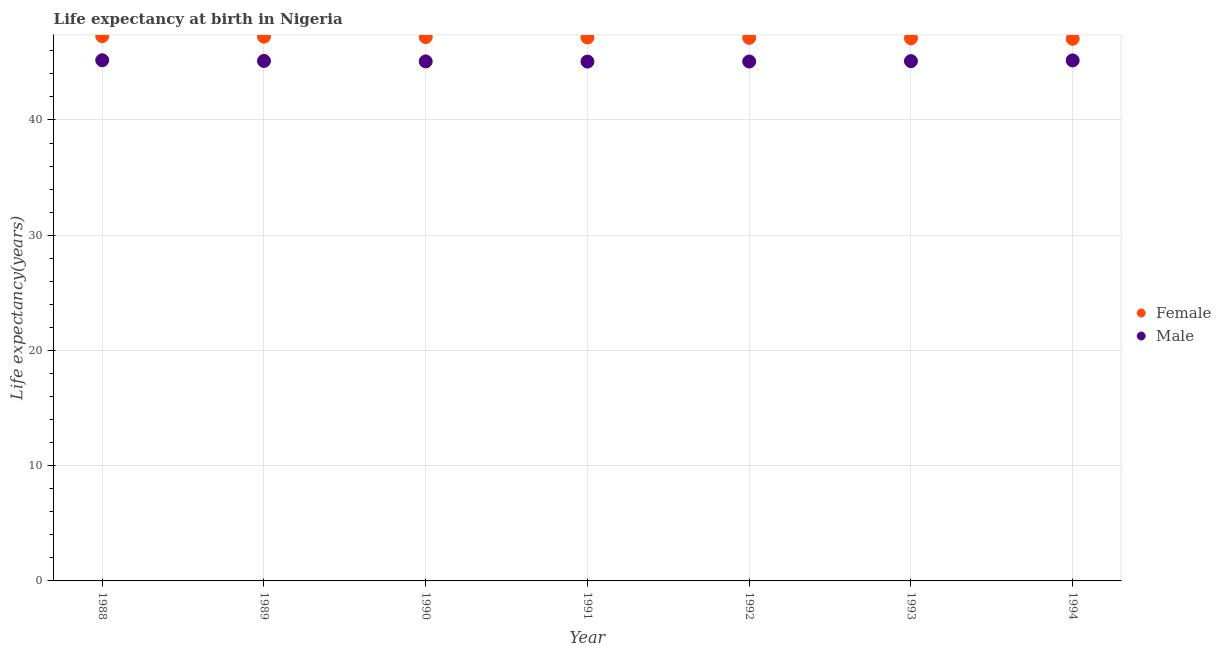How many different coloured dotlines are there?
Offer a terse response. 2. Is the number of dotlines equal to the number of legend labels?
Give a very brief answer. Yes. What is the life expectancy(male) in 1993?
Keep it short and to the point. 45.11. Across all years, what is the maximum life expectancy(female)?
Offer a very short reply. 47.27. Across all years, what is the minimum life expectancy(male)?
Keep it short and to the point. 45.06. In which year was the life expectancy(female) maximum?
Give a very brief answer. 1988. What is the total life expectancy(male) in the graph?
Offer a terse response. 315.8. What is the difference between the life expectancy(female) in 1990 and that in 1993?
Keep it short and to the point. 0.1. What is the difference between the life expectancy(male) in 1990 and the life expectancy(female) in 1991?
Offer a terse response. -2.08. What is the average life expectancy(female) per year?
Keep it short and to the point. 47.16. In the year 1989, what is the difference between the life expectancy(female) and life expectancy(male)?
Ensure brevity in your answer.  2.1. In how many years, is the life expectancy(male) greater than 32 years?
Make the answer very short. 7. What is the ratio of the life expectancy(male) in 1989 to that in 1991?
Make the answer very short. 1. Is the difference between the life expectancy(female) in 1989 and 1991 greater than the difference between the life expectancy(male) in 1989 and 1991?
Keep it short and to the point. Yes. What is the difference between the highest and the second highest life expectancy(female)?
Your response must be concise. 0.05. What is the difference between the highest and the lowest life expectancy(male)?
Offer a very short reply. 0.12. Is the life expectancy(male) strictly greater than the life expectancy(female) over the years?
Offer a terse response. No. Is the life expectancy(male) strictly less than the life expectancy(female) over the years?
Keep it short and to the point. Yes. Are the values on the major ticks of Y-axis written in scientific E-notation?
Ensure brevity in your answer.  No. Where does the legend appear in the graph?
Offer a terse response. Center right. What is the title of the graph?
Provide a succinct answer. Life expectancy at birth in Nigeria. What is the label or title of the Y-axis?
Provide a short and direct response. Life expectancy(years). What is the Life expectancy(years) in Female in 1988?
Your response must be concise. 47.27. What is the Life expectancy(years) of Male in 1988?
Your response must be concise. 45.18. What is the Life expectancy(years) in Female in 1989?
Provide a succinct answer. 47.23. What is the Life expectancy(years) of Male in 1989?
Make the answer very short. 45.12. What is the Life expectancy(years) in Female in 1990?
Give a very brief answer. 47.19. What is the Life expectancy(years) in Male in 1990?
Give a very brief answer. 45.08. What is the Life expectancy(years) in Female in 1991?
Offer a very short reply. 47.16. What is the Life expectancy(years) in Male in 1991?
Ensure brevity in your answer.  45.06. What is the Life expectancy(years) in Female in 1992?
Offer a very short reply. 47.13. What is the Life expectancy(years) of Male in 1992?
Your answer should be compact. 45.07. What is the Life expectancy(years) of Female in 1993?
Make the answer very short. 47.09. What is the Life expectancy(years) of Male in 1993?
Provide a short and direct response. 45.11. What is the Life expectancy(years) of Female in 1994?
Your response must be concise. 47.05. What is the Life expectancy(years) in Male in 1994?
Make the answer very short. 45.17. Across all years, what is the maximum Life expectancy(years) of Female?
Offer a terse response. 47.27. Across all years, what is the maximum Life expectancy(years) in Male?
Ensure brevity in your answer.  45.18. Across all years, what is the minimum Life expectancy(years) in Female?
Your answer should be compact. 47.05. Across all years, what is the minimum Life expectancy(years) of Male?
Make the answer very short. 45.06. What is the total Life expectancy(years) of Female in the graph?
Ensure brevity in your answer.  330.12. What is the total Life expectancy(years) of Male in the graph?
Ensure brevity in your answer.  315.8. What is the difference between the Life expectancy(years) in Female in 1988 and that in 1989?
Give a very brief answer. 0.05. What is the difference between the Life expectancy(years) in Male in 1988 and that in 1989?
Make the answer very short. 0.06. What is the difference between the Life expectancy(years) in Female in 1988 and that in 1990?
Your response must be concise. 0.08. What is the difference between the Life expectancy(years) in Male in 1988 and that in 1990?
Offer a terse response. 0.1. What is the difference between the Life expectancy(years) of Female in 1988 and that in 1991?
Your answer should be compact. 0.11. What is the difference between the Life expectancy(years) in Male in 1988 and that in 1991?
Give a very brief answer. 0.12. What is the difference between the Life expectancy(years) in Female in 1988 and that in 1992?
Offer a very short reply. 0.15. What is the difference between the Life expectancy(years) of Male in 1988 and that in 1992?
Offer a terse response. 0.11. What is the difference between the Life expectancy(years) of Female in 1988 and that in 1993?
Give a very brief answer. 0.19. What is the difference between the Life expectancy(years) of Male in 1988 and that in 1993?
Give a very brief answer. 0.08. What is the difference between the Life expectancy(years) of Female in 1988 and that in 1994?
Ensure brevity in your answer.  0.23. What is the difference between the Life expectancy(years) in Male in 1988 and that in 1994?
Your answer should be very brief. 0.01. What is the difference between the Life expectancy(years) of Female in 1989 and that in 1990?
Offer a very short reply. 0.04. What is the difference between the Life expectancy(years) of Male in 1989 and that in 1990?
Offer a terse response. 0.04. What is the difference between the Life expectancy(years) of Female in 1989 and that in 1991?
Your response must be concise. 0.07. What is the difference between the Life expectancy(years) of Male in 1989 and that in 1991?
Offer a terse response. 0.06. What is the difference between the Life expectancy(years) in Female in 1989 and that in 1992?
Your answer should be compact. 0.1. What is the difference between the Life expectancy(years) in Female in 1989 and that in 1993?
Your response must be concise. 0.14. What is the difference between the Life expectancy(years) of Male in 1989 and that in 1993?
Offer a terse response. 0.02. What is the difference between the Life expectancy(years) in Female in 1989 and that in 1994?
Offer a terse response. 0.18. What is the difference between the Life expectancy(years) in Male in 1989 and that in 1994?
Make the answer very short. -0.04. What is the difference between the Life expectancy(years) in Female in 1990 and that in 1991?
Your answer should be compact. 0.03. What is the difference between the Life expectancy(years) of Male in 1990 and that in 1991?
Offer a very short reply. 0.02. What is the difference between the Life expectancy(years) in Female in 1990 and that in 1992?
Keep it short and to the point. 0.06. What is the difference between the Life expectancy(years) of Male in 1990 and that in 1992?
Provide a short and direct response. 0.01. What is the difference between the Life expectancy(years) of Female in 1990 and that in 1993?
Ensure brevity in your answer.  0.1. What is the difference between the Life expectancy(years) of Male in 1990 and that in 1993?
Your response must be concise. -0.03. What is the difference between the Life expectancy(years) in Female in 1990 and that in 1994?
Offer a terse response. 0.14. What is the difference between the Life expectancy(years) in Male in 1990 and that in 1994?
Provide a short and direct response. -0.09. What is the difference between the Life expectancy(years) of Female in 1991 and that in 1992?
Your response must be concise. 0.03. What is the difference between the Life expectancy(years) in Male in 1991 and that in 1992?
Ensure brevity in your answer.  -0.01. What is the difference between the Life expectancy(years) of Female in 1991 and that in 1993?
Offer a very short reply. 0.07. What is the difference between the Life expectancy(years) in Male in 1991 and that in 1993?
Offer a terse response. -0.04. What is the difference between the Life expectancy(years) of Female in 1991 and that in 1994?
Offer a very short reply. 0.11. What is the difference between the Life expectancy(years) in Male in 1991 and that in 1994?
Offer a terse response. -0.1. What is the difference between the Life expectancy(years) of Female in 1992 and that in 1993?
Give a very brief answer. 0.04. What is the difference between the Life expectancy(years) in Male in 1992 and that in 1993?
Your answer should be compact. -0.03. What is the difference between the Life expectancy(years) of Female in 1992 and that in 1994?
Provide a short and direct response. 0.08. What is the difference between the Life expectancy(years) of Male in 1992 and that in 1994?
Make the answer very short. -0.1. What is the difference between the Life expectancy(years) of Female in 1993 and that in 1994?
Offer a very short reply. 0.04. What is the difference between the Life expectancy(years) in Male in 1993 and that in 1994?
Offer a terse response. -0.06. What is the difference between the Life expectancy(years) in Female in 1988 and the Life expectancy(years) in Male in 1989?
Offer a terse response. 2.15. What is the difference between the Life expectancy(years) of Female in 1988 and the Life expectancy(years) of Male in 1990?
Provide a succinct answer. 2.19. What is the difference between the Life expectancy(years) of Female in 1988 and the Life expectancy(years) of Male in 1991?
Provide a succinct answer. 2.21. What is the difference between the Life expectancy(years) of Female in 1988 and the Life expectancy(years) of Male in 1992?
Your response must be concise. 2.2. What is the difference between the Life expectancy(years) of Female in 1988 and the Life expectancy(years) of Male in 1993?
Provide a succinct answer. 2.17. What is the difference between the Life expectancy(years) of Female in 1988 and the Life expectancy(years) of Male in 1994?
Offer a terse response. 2.11. What is the difference between the Life expectancy(years) in Female in 1989 and the Life expectancy(years) in Male in 1990?
Offer a terse response. 2.15. What is the difference between the Life expectancy(years) in Female in 1989 and the Life expectancy(years) in Male in 1991?
Make the answer very short. 2.16. What is the difference between the Life expectancy(years) of Female in 1989 and the Life expectancy(years) of Male in 1992?
Offer a terse response. 2.15. What is the difference between the Life expectancy(years) in Female in 1989 and the Life expectancy(years) in Male in 1993?
Your answer should be compact. 2.12. What is the difference between the Life expectancy(years) in Female in 1989 and the Life expectancy(years) in Male in 1994?
Give a very brief answer. 2.06. What is the difference between the Life expectancy(years) of Female in 1990 and the Life expectancy(years) of Male in 1991?
Make the answer very short. 2.13. What is the difference between the Life expectancy(years) in Female in 1990 and the Life expectancy(years) in Male in 1992?
Offer a very short reply. 2.12. What is the difference between the Life expectancy(years) in Female in 1990 and the Life expectancy(years) in Male in 1993?
Your response must be concise. 2.08. What is the difference between the Life expectancy(years) of Female in 1990 and the Life expectancy(years) of Male in 1994?
Your answer should be very brief. 2.02. What is the difference between the Life expectancy(years) of Female in 1991 and the Life expectancy(years) of Male in 1992?
Provide a succinct answer. 2.09. What is the difference between the Life expectancy(years) of Female in 1991 and the Life expectancy(years) of Male in 1993?
Your response must be concise. 2.05. What is the difference between the Life expectancy(years) in Female in 1991 and the Life expectancy(years) in Male in 1994?
Ensure brevity in your answer.  1.99. What is the difference between the Life expectancy(years) of Female in 1992 and the Life expectancy(years) of Male in 1993?
Offer a very short reply. 2.02. What is the difference between the Life expectancy(years) in Female in 1992 and the Life expectancy(years) in Male in 1994?
Your answer should be very brief. 1.96. What is the difference between the Life expectancy(years) of Female in 1993 and the Life expectancy(years) of Male in 1994?
Provide a succinct answer. 1.92. What is the average Life expectancy(years) of Female per year?
Offer a terse response. 47.16. What is the average Life expectancy(years) in Male per year?
Offer a very short reply. 45.11. In the year 1988, what is the difference between the Life expectancy(years) in Female and Life expectancy(years) in Male?
Ensure brevity in your answer.  2.09. In the year 1989, what is the difference between the Life expectancy(years) of Female and Life expectancy(years) of Male?
Ensure brevity in your answer.  2.1. In the year 1990, what is the difference between the Life expectancy(years) in Female and Life expectancy(years) in Male?
Your answer should be compact. 2.11. In the year 1991, what is the difference between the Life expectancy(years) in Female and Life expectancy(years) in Male?
Provide a succinct answer. 2.1. In the year 1992, what is the difference between the Life expectancy(years) in Female and Life expectancy(years) in Male?
Offer a very short reply. 2.05. In the year 1993, what is the difference between the Life expectancy(years) in Female and Life expectancy(years) in Male?
Keep it short and to the point. 1.98. In the year 1994, what is the difference between the Life expectancy(years) in Female and Life expectancy(years) in Male?
Offer a terse response. 1.88. What is the ratio of the Life expectancy(years) of Female in 1988 to that in 1989?
Ensure brevity in your answer.  1. What is the ratio of the Life expectancy(years) of Male in 1988 to that in 1989?
Offer a terse response. 1. What is the ratio of the Life expectancy(years) in Female in 1988 to that in 1990?
Provide a short and direct response. 1. What is the ratio of the Life expectancy(years) in Male in 1988 to that in 1990?
Provide a succinct answer. 1. What is the ratio of the Life expectancy(years) of Male in 1988 to that in 1991?
Your answer should be very brief. 1. What is the ratio of the Life expectancy(years) of Female in 1988 to that in 1994?
Your answer should be compact. 1. What is the ratio of the Life expectancy(years) in Female in 1989 to that in 1990?
Make the answer very short. 1. What is the ratio of the Life expectancy(years) of Female in 1989 to that in 1992?
Make the answer very short. 1. What is the ratio of the Life expectancy(years) of Male in 1989 to that in 1993?
Make the answer very short. 1. What is the ratio of the Life expectancy(years) in Female in 1990 to that in 1991?
Ensure brevity in your answer.  1. What is the ratio of the Life expectancy(years) in Male in 1990 to that in 1992?
Your response must be concise. 1. What is the ratio of the Life expectancy(years) in Male in 1991 to that in 1992?
Ensure brevity in your answer.  1. What is the ratio of the Life expectancy(years) in Female in 1991 to that in 1993?
Provide a short and direct response. 1. What is the ratio of the Life expectancy(years) of Male in 1991 to that in 1993?
Your answer should be very brief. 1. What is the ratio of the Life expectancy(years) in Female in 1991 to that in 1994?
Make the answer very short. 1. What is the ratio of the Life expectancy(years) in Female in 1992 to that in 1993?
Provide a short and direct response. 1. What is the ratio of the Life expectancy(years) of Male in 1992 to that in 1993?
Your answer should be very brief. 1. What is the difference between the highest and the second highest Life expectancy(years) in Female?
Your response must be concise. 0.05. What is the difference between the highest and the second highest Life expectancy(years) in Male?
Keep it short and to the point. 0.01. What is the difference between the highest and the lowest Life expectancy(years) in Female?
Ensure brevity in your answer.  0.23. What is the difference between the highest and the lowest Life expectancy(years) of Male?
Your response must be concise. 0.12. 